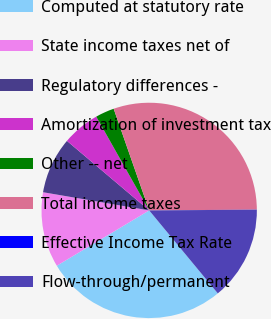Convert chart to OTSL. <chart><loc_0><loc_0><loc_500><loc_500><pie_chart><fcel>Computed at statutory rate<fcel>State income taxes net of<fcel>Regulatory differences -<fcel>Amortization of investment tax<fcel>Other -- net<fcel>Total income taxes<fcel>Effective Income Tax Rate<fcel>Flow-through/permanent<nl><fcel>27.41%<fcel>11.29%<fcel>8.47%<fcel>5.65%<fcel>2.83%<fcel>30.23%<fcel>0.01%<fcel>14.11%<nl></chart> 